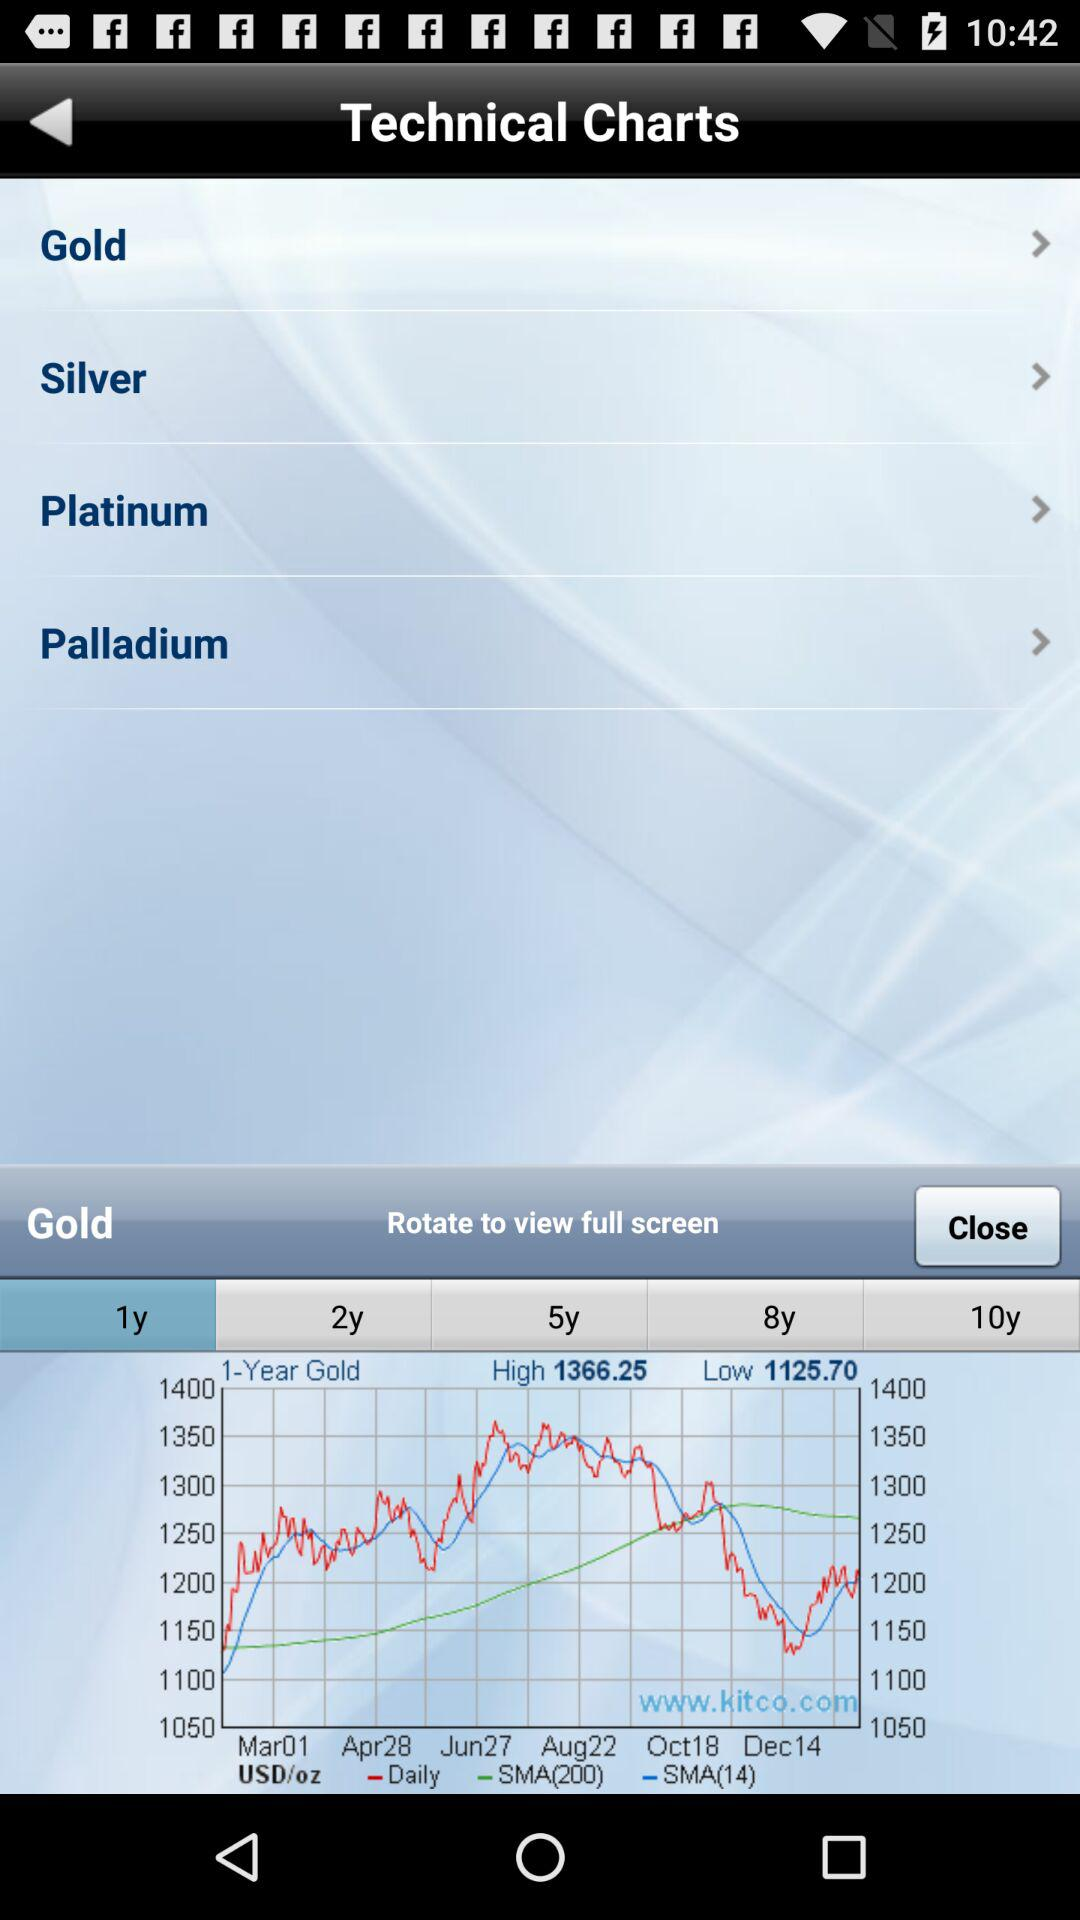Which time period is selected to display the graph? The selected time period is 1 year. 